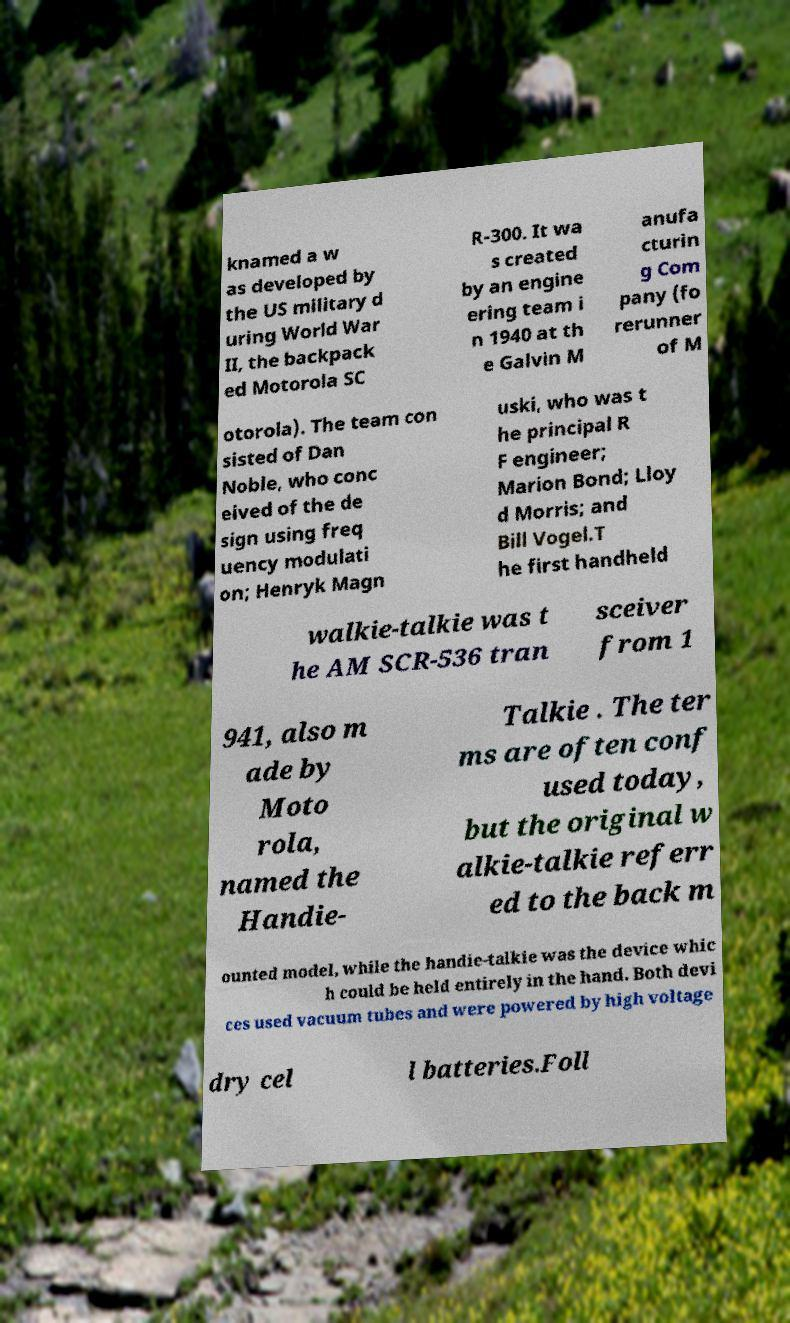Please read and relay the text visible in this image. What does it say? knamed a w as developed by the US military d uring World War II, the backpack ed Motorola SC R-300. It wa s created by an engine ering team i n 1940 at th e Galvin M anufa cturin g Com pany (fo rerunner of M otorola). The team con sisted of Dan Noble, who conc eived of the de sign using freq uency modulati on; Henryk Magn uski, who was t he principal R F engineer; Marion Bond; Lloy d Morris; and Bill Vogel.T he first handheld walkie-talkie was t he AM SCR-536 tran sceiver from 1 941, also m ade by Moto rola, named the Handie- Talkie . The ter ms are often conf used today, but the original w alkie-talkie referr ed to the back m ounted model, while the handie-talkie was the device whic h could be held entirely in the hand. Both devi ces used vacuum tubes and were powered by high voltage dry cel l batteries.Foll 